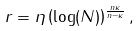Convert formula to latex. <formula><loc_0><loc_0><loc_500><loc_500>r = \eta \left ( \log ( N ) \right ) ^ { \frac { n \kappa } { n - \kappa } } ,</formula> 